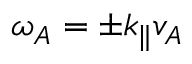Convert formula to latex. <formula><loc_0><loc_0><loc_500><loc_500>\omega _ { A } = \pm k _ { \| } v _ { A }</formula> 